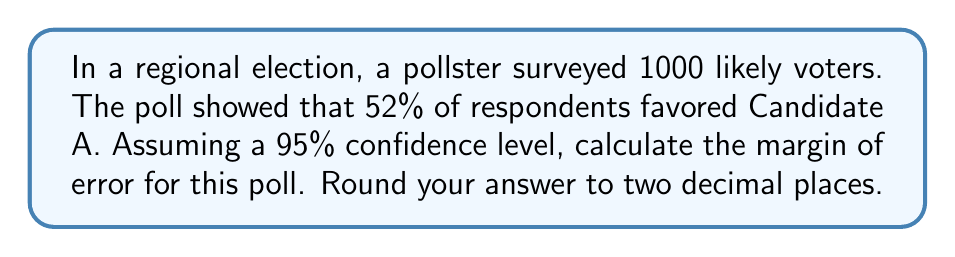Solve this math problem. To calculate the margin of error for this poll, we'll use the formula for the margin of error in a simple random sample:

$$ \text{Margin of Error} = z \times \sqrt{\frac{p(1-p)}{n}} $$

Where:
- $z$ is the z-score for the desired confidence level
- $p$ is the sample proportion
- $n$ is the sample size

Step 1: Determine the z-score for a 95% confidence level.
The z-score for a 95% confidence level is 1.96.

Step 2: Identify the values for the formula.
$z = 1.96$
$p = 0.52$ (52% expressed as a decimal)
$n = 1000$

Step 3: Plug the values into the formula.

$$ \text{Margin of Error} = 1.96 \times \sqrt{\frac{0.52(1-0.52)}{1000}} $$

Step 4: Calculate the result.

$$ \text{Margin of Error} = 1.96 \times \sqrt{\frac{0.52 \times 0.48}{1000}} $$
$$ = 1.96 \times \sqrt{0.0002496} $$
$$ = 1.96 \times 0.0158 $$
$$ = 0.030968 $$

Step 5: Round to two decimal places.

$$ \text{Margin of Error} = 0.03 \text{ or } 3\% $$

This means that we can be 95% confident that the true proportion of voters favoring Candidate A in the population is within 3 percentage points of the sample estimate of 52%.
Answer: 0.03 or 3% 